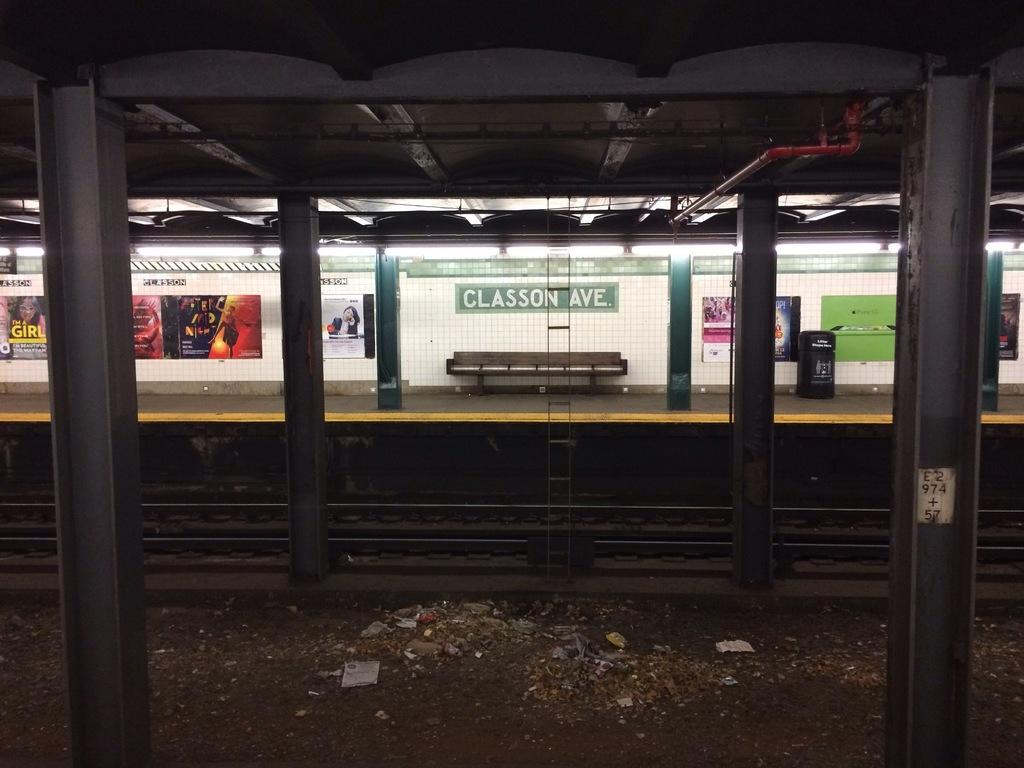What type of structure can be seen in the image? There are pillars in the image, which suggests a structure of some kind. What else is visible in the image? There is a railway track and a bench in the background of the image. What can be found attached to a wall in the image? There are boards attached to a wall in the image. What color is the wall in the image? The wall is white in color. Can you see any yams growing near the railway track in the image? There are no yams visible in the image; it features pillars, a railway track, a bench, boards attached to a wall, and a white wall. Is there a quill pen being used by someone in the image? There is no quill pen present in the image. 